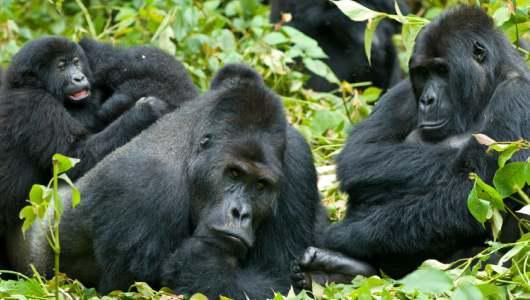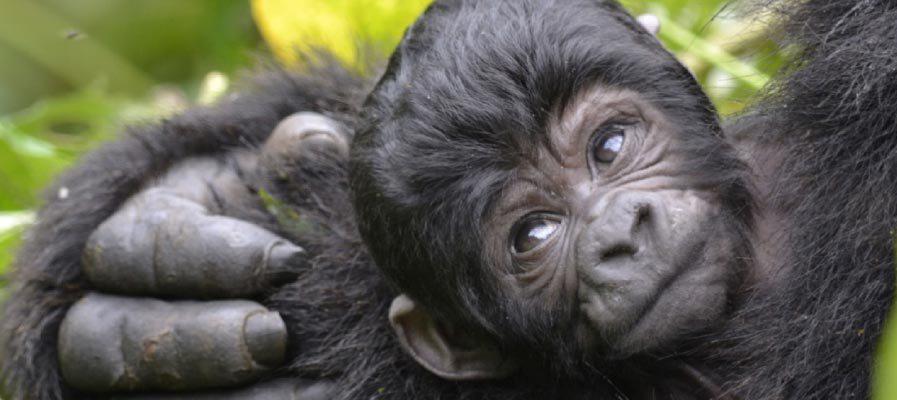The first image is the image on the left, the second image is the image on the right. Considering the images on both sides, is "In at least one image there are two gorillas with one adult holding a single baby." valid? Answer yes or no. No. The first image is the image on the left, the second image is the image on the right. Evaluate the accuracy of this statement regarding the images: "The right image shows curled gray fingers pointing toward the head of a forward-facing baby gorilla.". Is it true? Answer yes or no. Yes. 